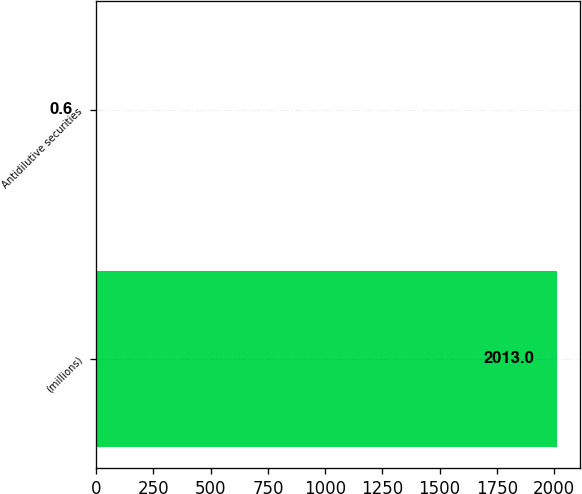<chart> <loc_0><loc_0><loc_500><loc_500><bar_chart><fcel>(millions)<fcel>Antidilutive securities<nl><fcel>2013<fcel>0.6<nl></chart> 